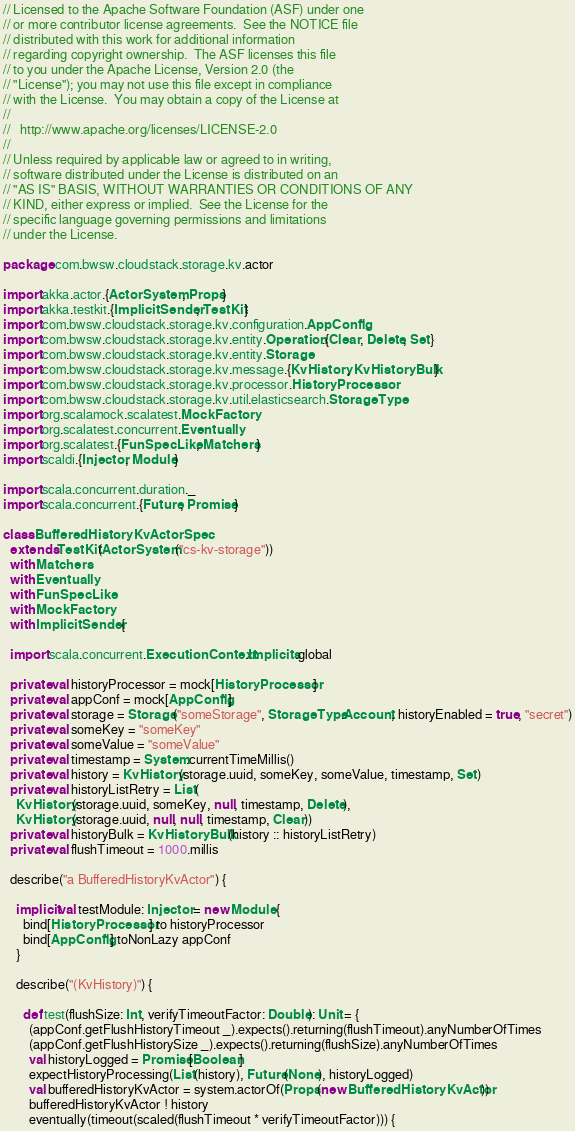Convert code to text. <code><loc_0><loc_0><loc_500><loc_500><_Scala_>// Licensed to the Apache Software Foundation (ASF) under one
// or more contributor license agreements.  See the NOTICE file
// distributed with this work for additional information
// regarding copyright ownership.  The ASF licenses this file
// to you under the Apache License, Version 2.0 (the
// "License"); you may not use this file except in compliance
// with the License.  You may obtain a copy of the License at
//
//   http://www.apache.org/licenses/LICENSE-2.0
//
// Unless required by applicable law or agreed to in writing,
// software distributed under the License is distributed on an
// "AS IS" BASIS, WITHOUT WARRANTIES OR CONDITIONS OF ANY
// KIND, either express or implied.  See the License for the
// specific language governing permissions and limitations
// under the License.

package com.bwsw.cloudstack.storage.kv.actor

import akka.actor.{ActorSystem, Props}
import akka.testkit.{ImplicitSender, TestKit}
import com.bwsw.cloudstack.storage.kv.configuration.AppConfig
import com.bwsw.cloudstack.storage.kv.entity.Operation.{Clear, Delete, Set}
import com.bwsw.cloudstack.storage.kv.entity.Storage
import com.bwsw.cloudstack.storage.kv.message.{KvHistory, KvHistoryBulk}
import com.bwsw.cloudstack.storage.kv.processor.HistoryProcessor
import com.bwsw.cloudstack.storage.kv.util.elasticsearch.StorageType
import org.scalamock.scalatest.MockFactory
import org.scalatest.concurrent.Eventually
import org.scalatest.{FunSpecLike, Matchers}
import scaldi.{Injector, Module}

import scala.concurrent.duration._
import scala.concurrent.{Future, Promise}

class BufferedHistoryKvActorSpec
  extends TestKit(ActorSystem("cs-kv-storage"))
  with Matchers
  with Eventually
  with FunSpecLike
  with MockFactory
  with ImplicitSender {

  import scala.concurrent.ExecutionContext.Implicits.global

  private val historyProcessor = mock[HistoryProcessor]
  private val appConf = mock[AppConfig]
  private val storage = Storage("someStorage", StorageType.Account, historyEnabled = true, "secret")
  private val someKey = "someKey"
  private val someValue = "someValue"
  private val timestamp = System.currentTimeMillis()
  private val history = KvHistory(storage.uuid, someKey, someValue, timestamp, Set)
  private val historyListRetry = List(
    KvHistory(storage.uuid, someKey, null, timestamp, Delete),
    KvHistory(storage.uuid, null, null, timestamp, Clear))
  private val historyBulk = KvHistoryBulk(history :: historyListRetry)
  private val flushTimeout = 1000.millis

  describe("a BufferedHistoryKvActor") {

    implicit val testModule: Injector = new Module {
      bind[HistoryProcessor] to historyProcessor
      bind[AppConfig] toNonLazy appConf
    }

    describe("(KvHistory)") {

      def test(flushSize: Int, verifyTimeoutFactor: Double): Unit = {
        (appConf.getFlushHistoryTimeout _).expects().returning(flushTimeout).anyNumberOfTimes
        (appConf.getFlushHistorySize _).expects().returning(flushSize).anyNumberOfTimes
        val historyLogged = Promise[Boolean]
        expectHistoryProcessing(List(history), Future(None), historyLogged)
        val bufferedHistoryKvActor = system.actorOf(Props(new BufferedHistoryKvActor))
        bufferedHistoryKvActor ! history
        eventually(timeout(scaled(flushTimeout * verifyTimeoutFactor))) {</code> 